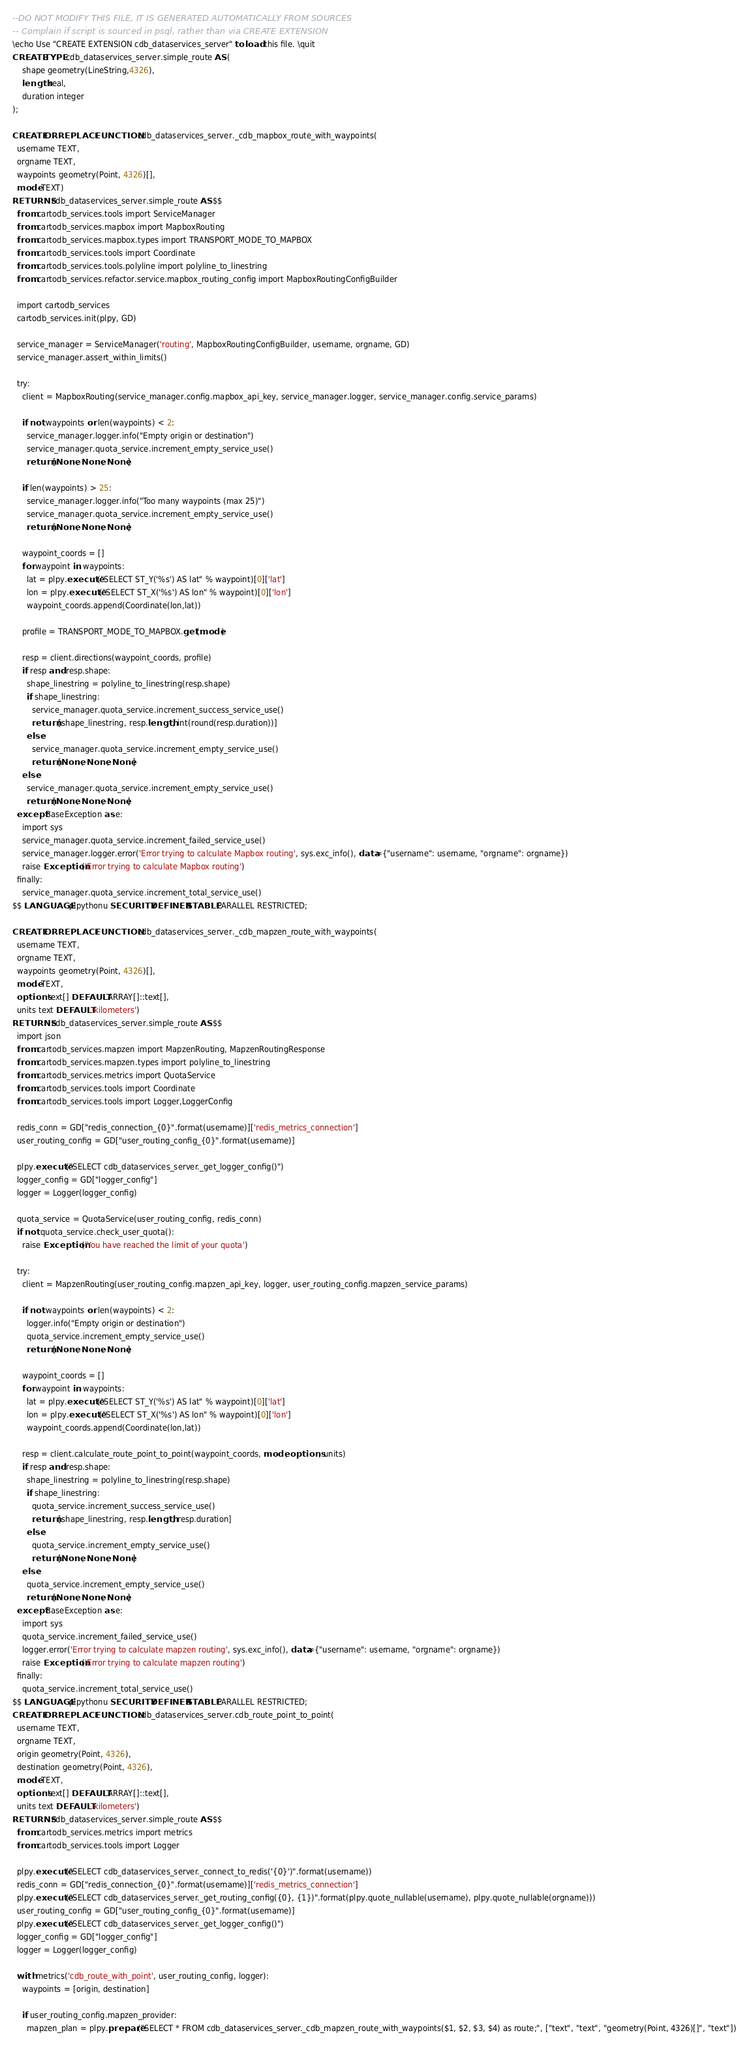<code> <loc_0><loc_0><loc_500><loc_500><_SQL_>--DO NOT MODIFY THIS FILE, IT IS GENERATED AUTOMATICALLY FROM SOURCES
-- Complain if script is sourced in psql, rather than via CREATE EXTENSION
\echo Use "CREATE EXTENSION cdb_dataservices_server" to load this file. \quit
CREATE TYPE cdb_dataservices_server.simple_route AS (
    shape geometry(LineString,4326),
    length real,
    duration integer
);

CREATE OR REPLACE FUNCTION cdb_dataservices_server._cdb_mapbox_route_with_waypoints(
  username TEXT,
  orgname TEXT,
  waypoints geometry(Point, 4326)[],
  mode TEXT)
RETURNS cdb_dataservices_server.simple_route AS $$
  from cartodb_services.tools import ServiceManager
  from cartodb_services.mapbox import MapboxRouting
  from cartodb_services.mapbox.types import TRANSPORT_MODE_TO_MAPBOX
  from cartodb_services.tools import Coordinate
  from cartodb_services.tools.polyline import polyline_to_linestring
  from cartodb_services.refactor.service.mapbox_routing_config import MapboxRoutingConfigBuilder

  import cartodb_services
  cartodb_services.init(plpy, GD)

  service_manager = ServiceManager('routing', MapboxRoutingConfigBuilder, username, orgname, GD)
  service_manager.assert_within_limits()

  try:
    client = MapboxRouting(service_manager.config.mapbox_api_key, service_manager.logger, service_manager.config.service_params)

    if not waypoints or len(waypoints) < 2:
      service_manager.logger.info("Empty origin or destination")
      service_manager.quota_service.increment_empty_service_use()
      return [None, None, None]

    if len(waypoints) > 25:
      service_manager.logger.info("Too many waypoints (max 25)")
      service_manager.quota_service.increment_empty_service_use()
      return [None, None, None]

    waypoint_coords = []
    for waypoint in waypoints:
      lat = plpy.execute("SELECT ST_Y('%s') AS lat" % waypoint)[0]['lat']
      lon = plpy.execute("SELECT ST_X('%s') AS lon" % waypoint)[0]['lon']
      waypoint_coords.append(Coordinate(lon,lat))

    profile = TRANSPORT_MODE_TO_MAPBOX.get(mode)

    resp = client.directions(waypoint_coords, profile)
    if resp and resp.shape:
      shape_linestring = polyline_to_linestring(resp.shape)
      if shape_linestring:
        service_manager.quota_service.increment_success_service_use()
        return [shape_linestring, resp.length, int(round(resp.duration))]
      else:
        service_manager.quota_service.increment_empty_service_use()
        return [None, None, None]
    else:
      service_manager.quota_service.increment_empty_service_use()
      return [None, None, None]
  except BaseException as e:
    import sys
    service_manager.quota_service.increment_failed_service_use()
    service_manager.logger.error('Error trying to calculate Mapbox routing', sys.exc_info(), data={"username": username, "orgname": orgname})
    raise Exception('Error trying to calculate Mapbox routing')
  finally:
    service_manager.quota_service.increment_total_service_use()
$$ LANGUAGE plpythonu SECURITY DEFINER STABLE PARALLEL RESTRICTED;

CREATE OR REPLACE FUNCTION cdb_dataservices_server._cdb_mapzen_route_with_waypoints(
  username TEXT,
  orgname TEXT,
  waypoints geometry(Point, 4326)[],
  mode TEXT,
  options text[] DEFAULT ARRAY[]::text[],
  units text DEFAULT 'kilometers')
RETURNS cdb_dataservices_server.simple_route AS $$
  import json
  from cartodb_services.mapzen import MapzenRouting, MapzenRoutingResponse
  from cartodb_services.mapzen.types import polyline_to_linestring
  from cartodb_services.metrics import QuotaService
  from cartodb_services.tools import Coordinate
  from cartodb_services.tools import Logger,LoggerConfig

  redis_conn = GD["redis_connection_{0}".format(username)]['redis_metrics_connection']
  user_routing_config = GD["user_routing_config_{0}".format(username)]

  plpy.execute("SELECT cdb_dataservices_server._get_logger_config()")
  logger_config = GD["logger_config"]
  logger = Logger(logger_config)

  quota_service = QuotaService(user_routing_config, redis_conn)
  if not quota_service.check_user_quota():
    raise Exception('You have reached the limit of your quota')

  try:
    client = MapzenRouting(user_routing_config.mapzen_api_key, logger, user_routing_config.mapzen_service_params)

    if not waypoints or len(waypoints) < 2:
      logger.info("Empty origin or destination")
      quota_service.increment_empty_service_use()
      return [None, None, None]

    waypoint_coords = []
    for waypoint in waypoints:
      lat = plpy.execute("SELECT ST_Y('%s') AS lat" % waypoint)[0]['lat']
      lon = plpy.execute("SELECT ST_X('%s') AS lon" % waypoint)[0]['lon']
      waypoint_coords.append(Coordinate(lon,lat))

    resp = client.calculate_route_point_to_point(waypoint_coords, mode, options, units)
    if resp and resp.shape:
      shape_linestring = polyline_to_linestring(resp.shape)
      if shape_linestring:
        quota_service.increment_success_service_use()
        return [shape_linestring, resp.length, resp.duration]
      else:
        quota_service.increment_empty_service_use()
        return [None, None, None]
    else:
      quota_service.increment_empty_service_use()
      return [None, None, None]
  except BaseException as e:
    import sys
    quota_service.increment_failed_service_use()
    logger.error('Error trying to calculate mapzen routing', sys.exc_info(), data={"username": username, "orgname": orgname})
    raise Exception('Error trying to calculate mapzen routing')
  finally:
    quota_service.increment_total_service_use()
$$ LANGUAGE plpythonu SECURITY DEFINER STABLE PARALLEL RESTRICTED;
CREATE OR REPLACE FUNCTION cdb_dataservices_server.cdb_route_point_to_point(
  username TEXT,
  orgname TEXT,
  origin geometry(Point, 4326),
  destination geometry(Point, 4326),
  mode TEXT,
  options text[] DEFAULT ARRAY[]::text[],
  units text DEFAULT 'kilometers')
RETURNS cdb_dataservices_server.simple_route AS $$
  from cartodb_services.metrics import metrics
  from cartodb_services.tools import Logger

  plpy.execute("SELECT cdb_dataservices_server._connect_to_redis('{0}')".format(username))
  redis_conn = GD["redis_connection_{0}".format(username)]['redis_metrics_connection']
  plpy.execute("SELECT cdb_dataservices_server._get_routing_config({0}, {1})".format(plpy.quote_nullable(username), plpy.quote_nullable(orgname)))
  user_routing_config = GD["user_routing_config_{0}".format(username)]
  plpy.execute("SELECT cdb_dataservices_server._get_logger_config()")
  logger_config = GD["logger_config"]
  logger = Logger(logger_config)

  with metrics('cdb_route_with_point', user_routing_config, logger):
    waypoints = [origin, destination]

    if user_routing_config.mapzen_provider:
      mapzen_plan = plpy.prepare("SELECT * FROM cdb_dataservices_server._cdb_mapzen_route_with_waypoints($1, $2, $3, $4) as route;", ["text", "text", "geometry(Point, 4326)[]", "text"])</code> 